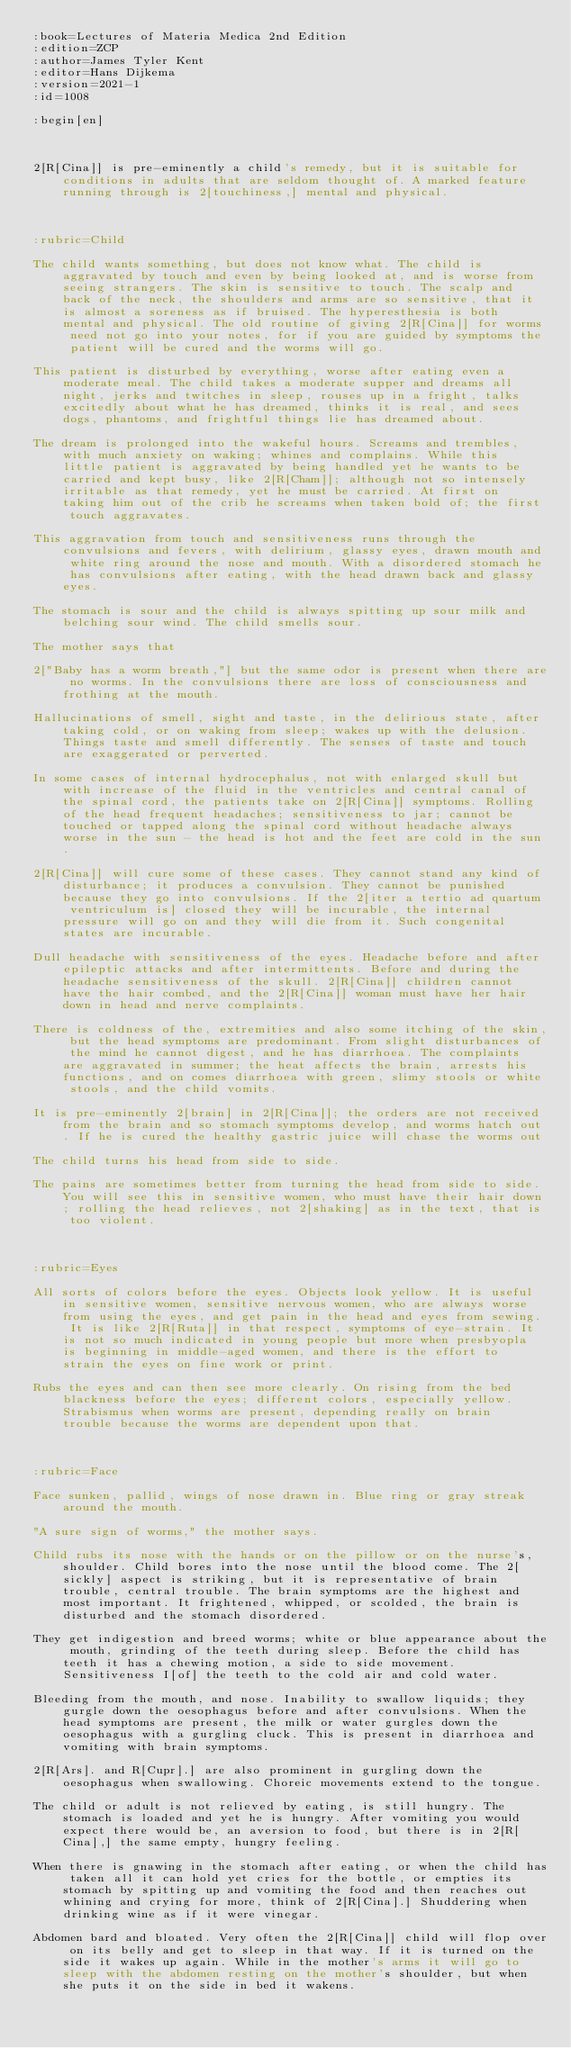Convert code to text. <code><loc_0><loc_0><loc_500><loc_500><_ObjectiveC_>:book=Lectures of Materia Medica 2nd Edition
:edition=ZCP
:author=James Tyler Kent
:editor=Hans Dijkema
:version=2021-1
:id=1008

:begin[en]



2[R[Cina]] is pre-eminently a child's remedy, but it is suitable for conditions in adults that are seldom thought of. A marked feature running through is 2[touchiness,] mental and physical.



:rubric=Child

The child wants something, but does not know what. The child is aggravated by touch and even by being looked at, and is worse from seeing strangers. The skin is sensitive to touch. The scalp and back of the neck, the shoulders and arms are so sensitive, that it is almost a soreness as if bruised. The hyperesthesia is both mental and physical. The old routine of giving 2[R[Cina]] for worms need not go into your notes, for if you are guided by symptoms the patient will be cured and the worms will go.

This patient is disturbed by everything, worse after eating even a moderate meal. The child takes a moderate supper and dreams all night, jerks and twitches in sleep, rouses up in a fright, talks excitedly about what he has dreamed, thinks it is real, and sees dogs, phantoms, and frightful things lie has dreamed about.

The dream is prolonged into the wakeful hours. Screams and trembles, with much anxiety on waking; whines and complains. While this little patient is aggravated by being handled yet he wants to be carried and kept busy, like 2[R[Cham]]; although not so intensely irritable as that remedy, yet he must be carried. At first on taking him out of the crib he screams when taken bold of; the first touch aggravates.

This aggravation from touch and sensitiveness runs through the convulsions and fevers, with delirium, glassy eyes, drawn mouth and white ring around the nose and mouth. With a disordered stomach he has convulsions after eating, with the head drawn back and glassy eyes.

The stomach is sour and the child is always spitting up sour milk and belching sour wind. The child smells sour.

The mother says that

2["Baby has a worm breath,"] but the same odor is present when there are no worms. In the convulsions there are loss of consciousness and frothing at the mouth.

Hallucinations of smell, sight and taste, in the delirious state, after taking cold, or on waking from sleep; wakes up with the delusion. Things taste and smell differently. The senses of taste and touch are exaggerated or perverted.

In some cases of internal hydrocephalus, not with enlarged skull but with increase of the fluid in the ventricles and central canal of the spinal cord, the patients take on 2[R[Cina]] symptoms. Rolling of the head frequent headaches; sensitiveness to jar; cannot be touched or tapped along the spinal cord without headache always worse in the sun - the head is hot and the feet are cold in the sun.

2[R[Cina]] will cure some of these cases. They cannot stand any kind of disturbance; it produces a convulsion. They cannot be punished because they go into convulsions. If the 2[iter a tertio ad quartum ventriculum is] closed they will be incurable, the internal pressure will go on and they will die from it. Such congenital states are incurable.

Dull headache with sensitiveness of the eyes. Headache before and after epileptic attacks and after intermittents. Before and during the headache sensitiveness of the skull. 2[R[Cina]] children cannot have the hair combed, and the 2[R[Cina]] woman must have her hair down in head and nerve complaints.

There is coldness of the, extremities and also some itching of the skin, but the head symptoms are predominant. From slight disturbances of the mind he cannot digest, and he has diarrhoea. The complaints are aggravated in summer; the heat affects the brain, arrests his functions, and on comes diarrhoea with green, slimy stools or white stools, and the child vomits.

It is pre-eminently 2[brain] in 2[R[Cina]]; the orders are not received from the brain and so stomach symptoms develop, and worms hatch out. If he is cured the healthy gastric juice will chase the worms out

The child turns his head from side to side.

The pains are sometimes better from turning the head from side to side. You will see this in sensitive women, who must have their hair down; rolling the head relieves, not 2[shaking] as in the text, that is too violent.



:rubric=Eyes

All sorts of colors before the eyes. Objects look yellow. It is useful in sensitive women, sensitive nervous women, who are always worse from using the eyes, and get pain in the head and eyes from sewing. It is like 2[R[Ruta]] in that respect, symptoms of eye-strain. It is not so much indicated in young people but more when presbyopla is beginning in middle-aged women, and there is the effort to strain the eyes on fine work or print.

Rubs the eyes and can then see more clearly. On rising from the bed blackness before the eyes; different colors, especially yellow. Strabismus when worms are present, depending really on brain trouble because the worms are dependent upon that.



:rubric=Face

Face sunken, pallid, wings of nose drawn in. Blue ring or gray streak around the mouth.

"A sure sign of worms," the mother says.

Child rubs its nose with the hands or on the pillow or on the nurse's, shoulder. Child bores into the nose until the blood come. The 2[sickly] aspect is striking, but it is representative of brain trouble, central trouble. The brain symptoms are the highest and most important. It frightened, whipped, or scolded, the brain is disturbed and the stomach disordered.

They get indigestion and breed worms; white or blue appearance about the mouth, grinding of the teeth during sleep. Before the child has teeth it has a chewing motion, a side to side movement. Sensitiveness I[of] the teeth to the cold air and cold water.

Bleeding from the mouth, and nose. Inability to swallow liquids; they gurgle down the oesophagus before and after convulsions. When the head symptoms are present, the milk or water gurgles down the oesophagus with a gurgling cluck. This is present in diarrhoea and vomiting with brain symptoms.

2[R[Ars]. and R[Cupr].] are also prominent in gurgling down the oesophagus when swallowing. Choreic movements extend to the tongue.

The child or adult is not relieved by eating, is still hungry. The stomach is loaded and yet he is hungry. After vomiting you would expect there would be, an aversion to food, but there is in 2[R[Cina],] the same empty, hungry feeling.

When there is gnawing in the stomach after eating, or when the child has taken all it can hold yet cries for the bottle, or empties its stomach by spitting up and vomiting the food and then reaches out whining and crying for more, think of 2[R[Cina].] Shuddering when drinking wine as if it were vinegar.

Abdomen bard and bloated. Very often the 2[R[Cina]] child will flop over on its belly and get to sleep in that way. If it is turned on the side it wakes up again. While in the mother's arms it will go to sleep with the abdomen resting on the mother's shoulder, but when she puts it on the side in bed it wakens.
</code> 